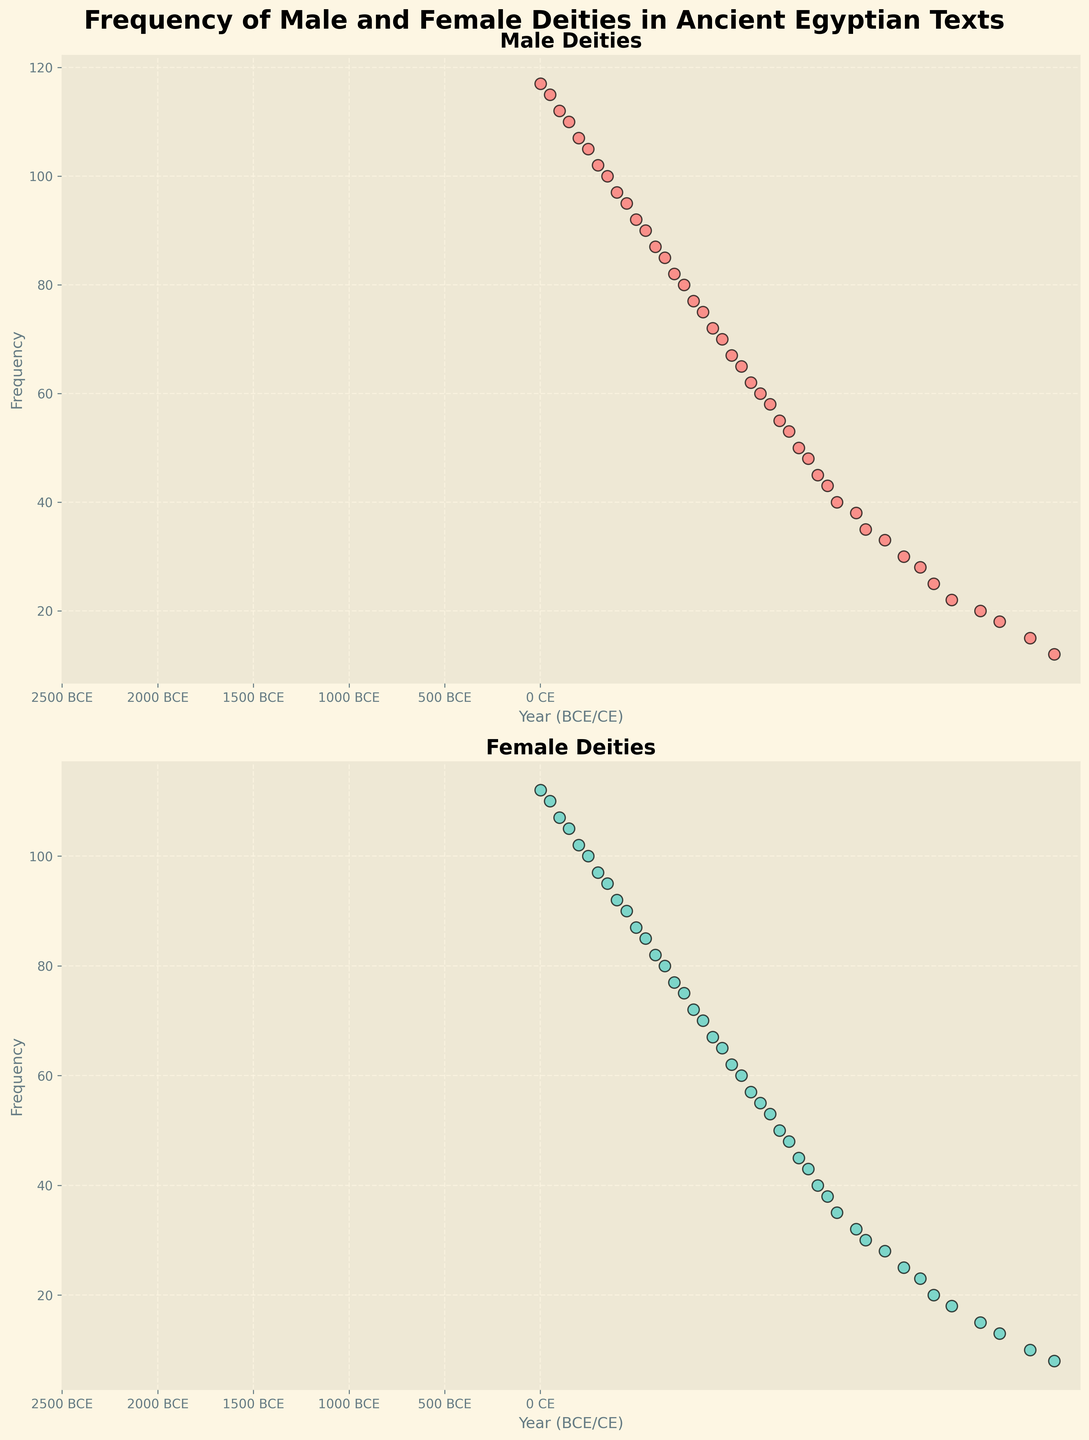What's the frequency of female deities in the year 200 BCE? Looking at the plot for female deities, we can see the y-axis value corresponding to 200 BCE.
Answer: 102 Compare the frequency of male and female deities in the year 500 BCE. Which one is higher and by how much? Looking at both plots, in the year 500 BCE, male deities have a frequency of 92 and female deities have a frequency of 87. The difference is 92 - 87.
Answer: Male deities, by 5 What is the total frequency of male deities between 1500 BCE and 1000 BCE? Referring to the plot for male deities, identify and sum the frequencies at the intervals: 1500 BCE (43), 1450 BCE (45), 1400 BCE (48), 1350 BCE (50), 1300 BCE (53), 1250 BCE (55), 1200 BCE (58), 1150 BCE (60), 1100 BCE (62), 1050 BCE (65), 1000 BCE (67). Sum these values.
Answer: 606 By how much did the frequency of female deities increase from 2686 BCE to 1 CE? Identify the frequency values at 2686 BCE (8) and 1 CE (112) for female deities. Compute the difference: 112 - 8.
Answer: 104 Around which time period did the frequency of male deities first reach 50? Locate the time period on the male deities' plot where the frequency value is 50.
Answer: 1350 BCE What is the difference in the frequencies of male and female deities in 1 CE? Locate the frequencies for male (117) and female (112) deities in 1 CE. Compute the difference: 117 - 112.
Answer: 5 Is there a time period when the frequency of female deities was exactly half the frequency of male deities? If so, what is that time period? Compare the frequencies of female and male deities across time points. At 1700 BCE, male deities are 35 and female deities are 17.5 (approximately 17).
Answer: 1700 BCE What is the average frequency of male deities across the depicted timeline? Sum the frequencies of male deities and divide by the number of data points (43): (12 + 15 + 18 + 20 + 22 + 25 + 28 + 30 + 33 + 35 + 38 + 40 + 43 + 45 + 48 + 50 + 53 + 55 + 58 + 60 + 62 + 65 + 67 + 70 + 72 + 75 + 77 + 80 + 82 + 85 + 87 + 90 + 92 + 95 + 97 + 100 + 102 + 105 + 107 + 110 + 112 + 115 + 117) / 43.
Answer: 59 During which centuries (100-year periods) did the frequencies of male and female deities increase most rapidly? Estimate the frequency increment per century from the plot, noting significant rises. For male deities, the greatest increase is between 150 BCE and 50 BCE (75 to 110, 35 units). For female deities, it's the same period (70 to 105, 35 units).
Answer: 2nd century BCE to 1st century CE In which time period did the frequency of male deities surpass 60? Locate the frequency progression on the male deities' plot. The frequency surpasses 60 between 1150 BCE and 1050 BCE.
Answer: Between 1150 BCE and 1050 BCE 